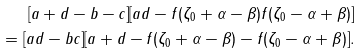Convert formula to latex. <formula><loc_0><loc_0><loc_500><loc_500>[ a + d - b - c ] [ a d - f ( \zeta _ { 0 } + \alpha - \beta ) f ( \zeta _ { 0 } - \alpha + \beta ) ] \\ = [ a d - b c ] [ a + d - f ( \zeta _ { 0 } + \alpha - \beta ) - f ( \zeta _ { 0 } - \alpha + \beta ) ] .</formula> 